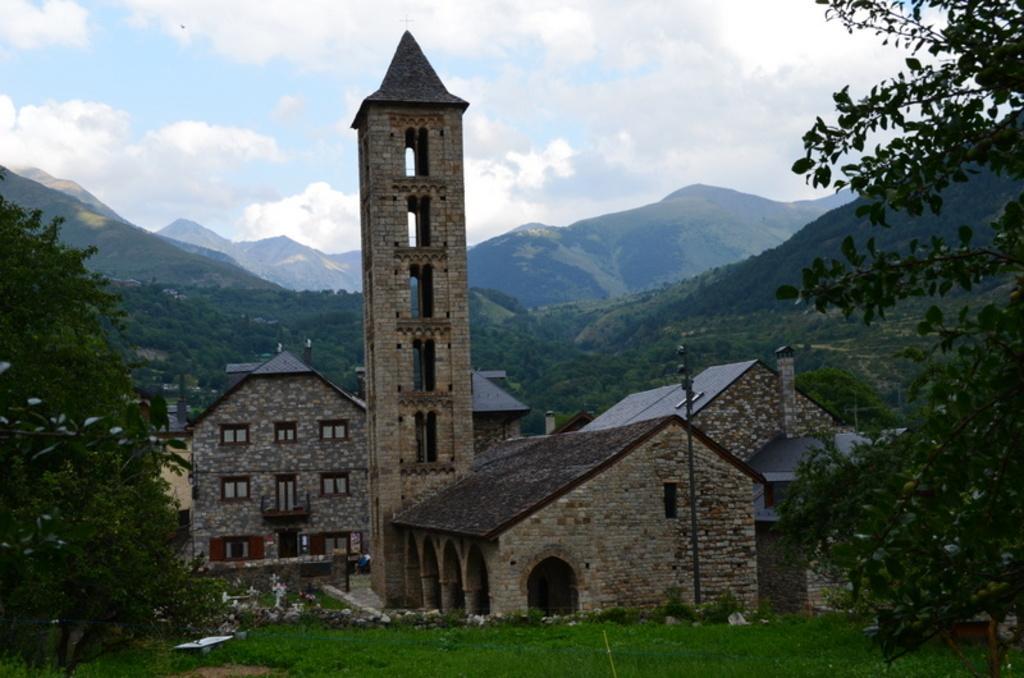Describe this image in one or two sentences. This picture might be taken from outside of the city. In this image, in the middle, we can see some buildings and towers. On the right side, we can see some trees. On the left side, we can also see some trees. In the background, we can see some trees, mountains, trees, plants. At the top, we can see a sky, at the bottom there is a grass and few plants. 